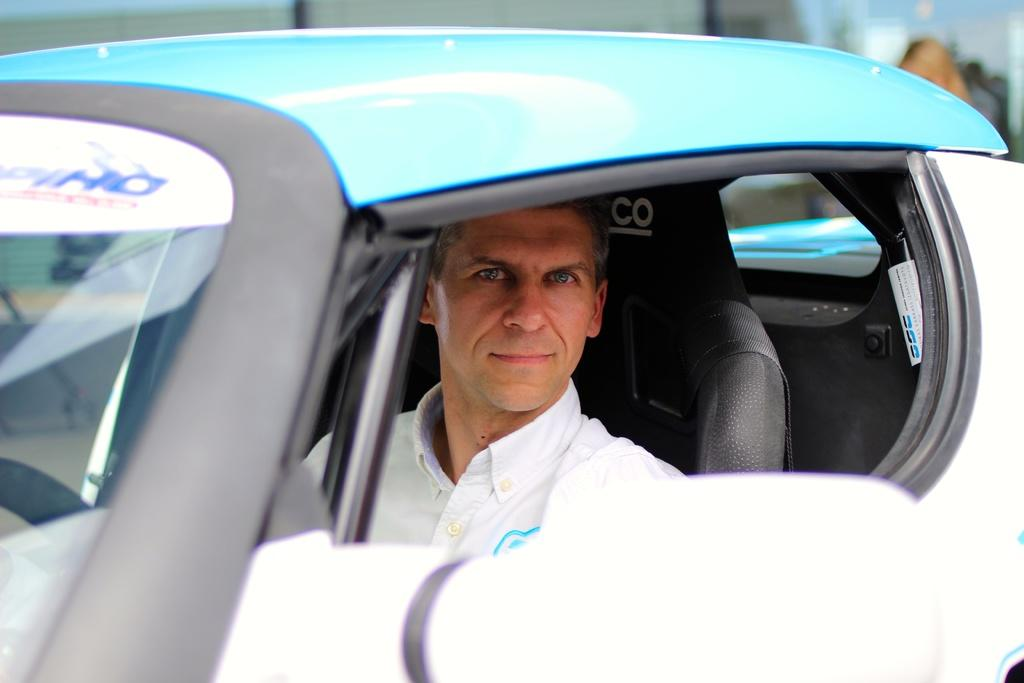What is present in the image? There is a man in the image. What is the man doing in the image? The man is sitting in a car. Can you see any mountains in the background of the image? There is no mention of mountains in the background of the image. Is the man standing on a border in the image? There is no mention of a border in the image. 